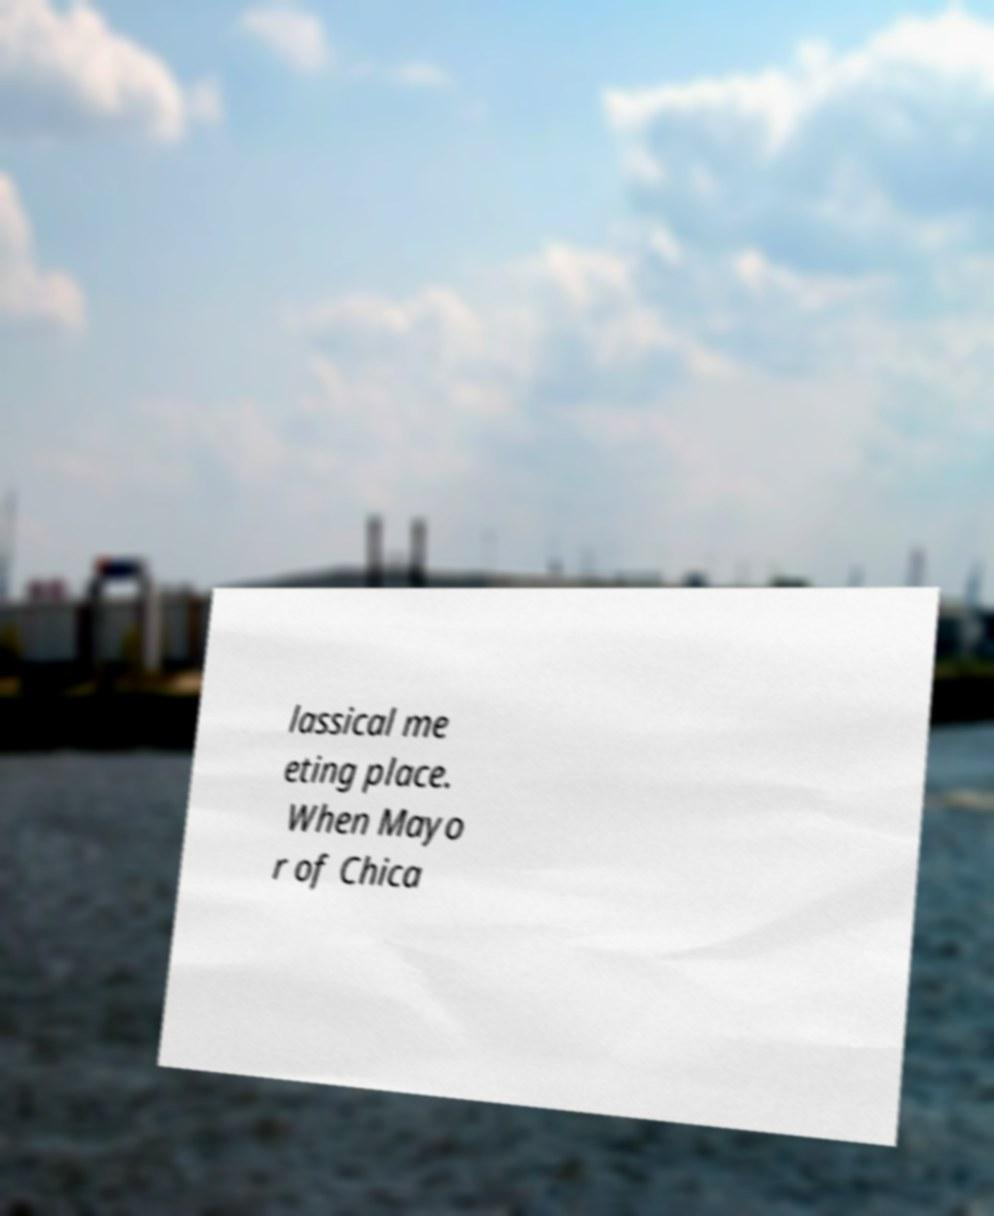Could you assist in decoding the text presented in this image and type it out clearly? lassical me eting place. When Mayo r of Chica 